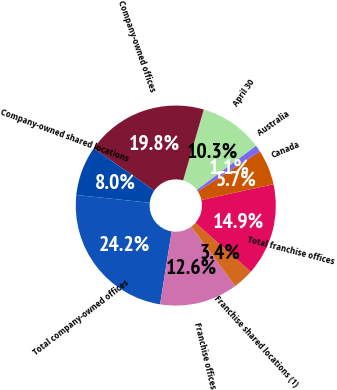Convert chart to OTSL. <chart><loc_0><loc_0><loc_500><loc_500><pie_chart><fcel>April 30<fcel>Company-owned offices<fcel>Company-owned shared locations<fcel>Total company-owned offices<fcel>Franchise offices<fcel>Franchise shared locations (1)<fcel>Total franchise offices<fcel>Canada<fcel>Australia<nl><fcel>10.31%<fcel>19.83%<fcel>8.0%<fcel>24.18%<fcel>12.62%<fcel>3.38%<fcel>14.93%<fcel>5.69%<fcel>1.07%<nl></chart> 